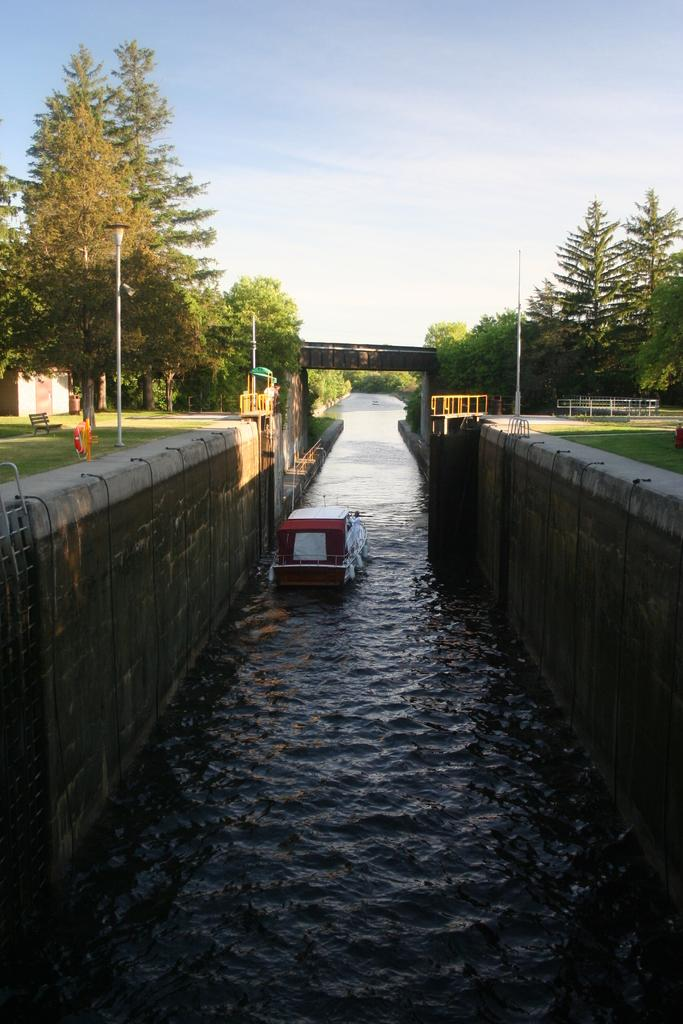What is the main subject of the image? The main subject of the image is a boat. What can be seen in the background of the image? There are trees on both sides of the image, and there is water visible in the image. What type of seating is available in the image? There are benches in the image. What structures are present in the image? Light poles and a bridge are present in the image. What is the color of the sky in the image? The sky is blue and white in color. How many ducks are swimming near the boat in the image? There are no ducks present in the image. What is the sister of the person taking the picture doing in the image? There is no person taking the picture, and no sister is mentioned in the provided facts. 